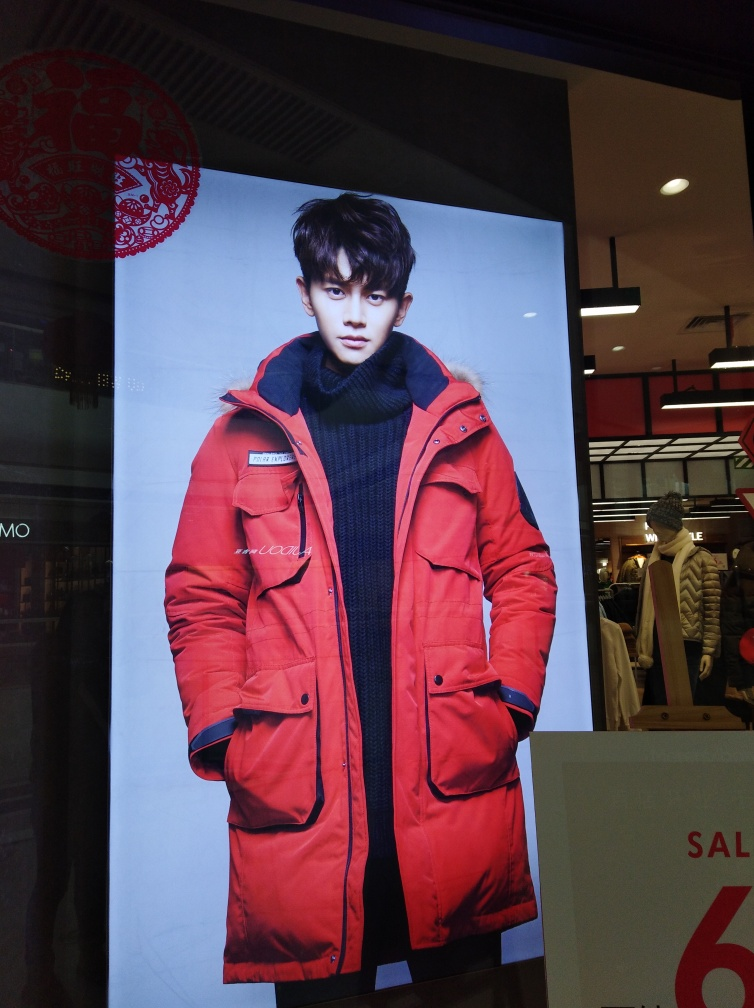Could you describe the setting or environment where this advertisement is displayed? The advertisement is displayed in a retail setting with a juxtaposition of modern interior elements and a traditional red paper cut decoration, suggesting a fusion of contemporary and cultural themes typically associated with festive sales or events. 